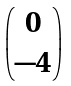<formula> <loc_0><loc_0><loc_500><loc_500>\begin{pmatrix} 0 \\ - 4 \end{pmatrix}</formula> 